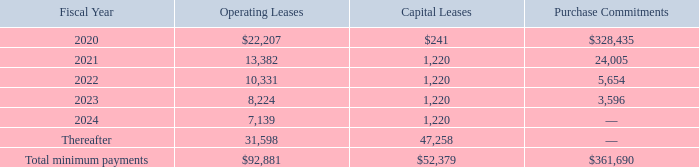Notes to Consolidated Financial Statements
Operating Leases
The Company leases certain of its corporate, manufacturing and other facilities from multiple third- party real estate developers. The operating leases expire at various dates through 2034, and some of these leases have renewal options, with the longest ranging up to two, ten-year periods. Several of these leases also include market rate rent escalations, rent holidays, and leasehold improvement incentives, all of which are recognized to expense on a straight-line basis. Leasehold improvements made either at the inception of the lease or during the lease term are amortized over the lesser of the remaining life of the lease term (including renewals that are reasonably assured) or the useful life of the asset. The Company also leases various machinery and equipment and office equipment under non-cancelable operating leases. The remaining terms of these operating leases range from less than one year to approximately 15 years.
Rent expense under operating leases, covering facilities and equipment, was approximately $19.3 million, $16.3 million, and $14.8 million for fiscal years 2019, 2018 and 2017, respectively.
Capital Leases
In fiscal 2018, the Company entered into a capital lease for a facility in Beijing, China that will allow the Company to consolidate several leased facilities as well as provide additional manufacturing space. The lease term is expected to commence in fiscal 2021 and therefore is not recorded on the Consolidated Balance Sheet as of March 30, 2019. The lease has an initial term of five years and includes multiple renewal options, with the maximum lease term not to exceed 30 years. The minimum future payments for this lease are included in the table below.
Purchase commitments
The Company’s other purchase commitments include payments due for materials and manufacturing services. The Company also has commitments for the purchase of property and equipment, a substantial majority of which will be due within the next 12 months.
The Company’s minimum payments under non-cancelable leases and purchase commitments as of March 30, 2019, are as follows (in thousands):
What are the company's respective operating leases and capital leases in 2020?
Answer scale should be: thousand. $22,207, $241. What are the company's respective operating leases and capital leases in 2021?
Answer scale should be: thousand. 13,382, 1,220. What are the company's respective operating leases and capital leases in 2022?
Answer scale should be: thousand. 10,331, 1,220. What is the company's total operating leases and capital leases in 2020?
Answer scale should be: thousand. $22,207 + $241 
Answer: 22448. What is the company's average operating lease in 2020 and 2021?
Answer scale should be: thousand. (22,207 + 13,382)/2 
Answer: 17794.5. What is the change in the company's operating leases in 2020 and 2021?
Answer scale should be: thousand. 22,207 - 13,382 
Answer: 8825. 